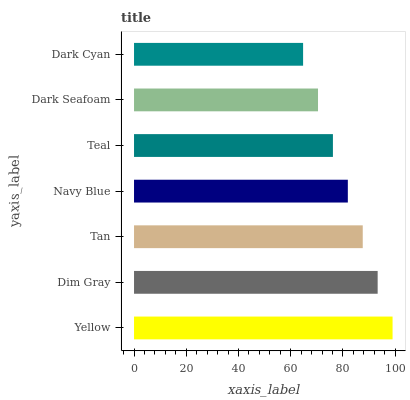Is Dark Cyan the minimum?
Answer yes or no. Yes. Is Yellow the maximum?
Answer yes or no. Yes. Is Dim Gray the minimum?
Answer yes or no. No. Is Dim Gray the maximum?
Answer yes or no. No. Is Yellow greater than Dim Gray?
Answer yes or no. Yes. Is Dim Gray less than Yellow?
Answer yes or no. Yes. Is Dim Gray greater than Yellow?
Answer yes or no. No. Is Yellow less than Dim Gray?
Answer yes or no. No. Is Navy Blue the high median?
Answer yes or no. Yes. Is Navy Blue the low median?
Answer yes or no. Yes. Is Yellow the high median?
Answer yes or no. No. Is Tan the low median?
Answer yes or no. No. 